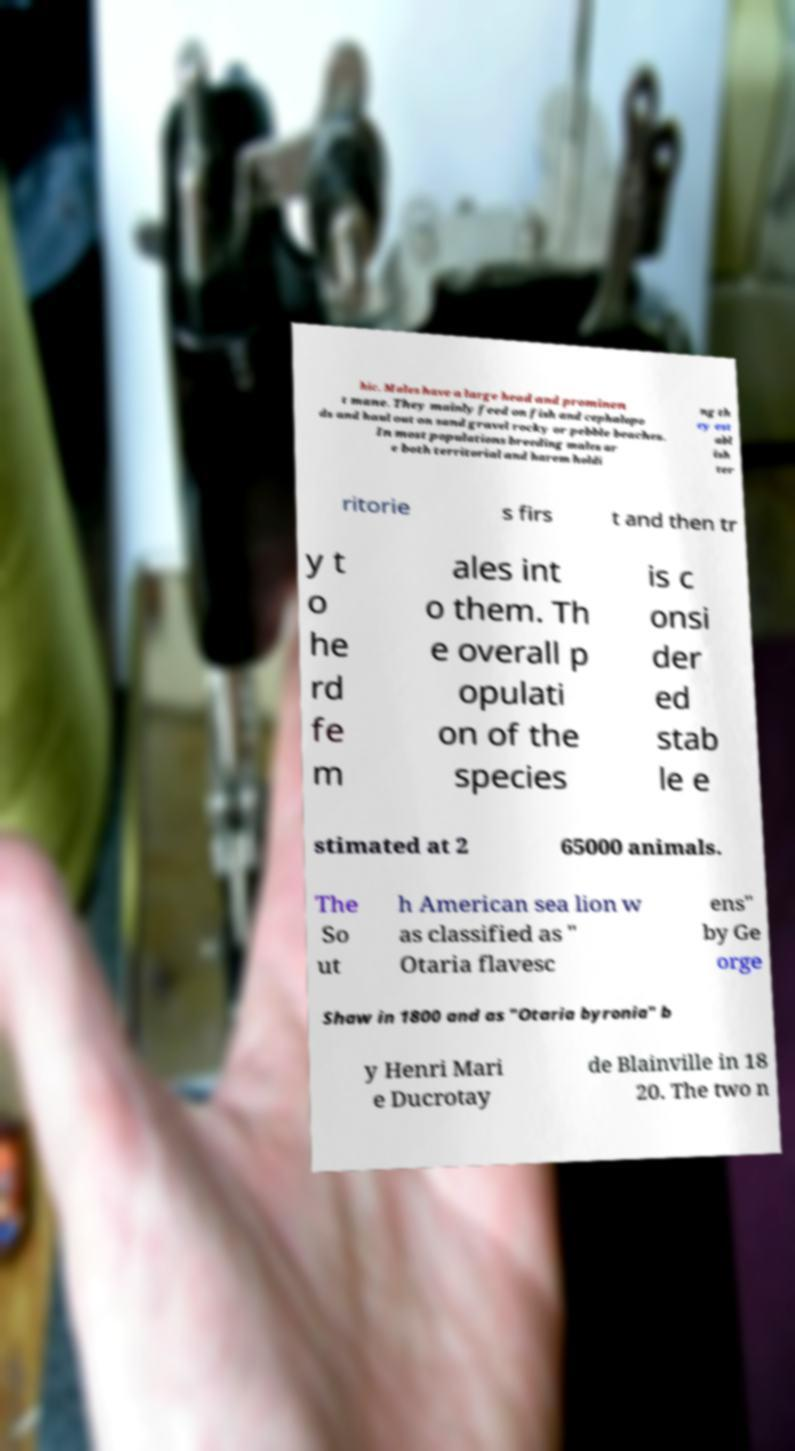Could you extract and type out the text from this image? hic. Males have a large head and prominen t mane. They mainly feed on fish and cephalopo ds and haul out on sand gravel rocky or pebble beaches. In most populations breeding males ar e both territorial and harem holdi ng th ey est abl ish ter ritorie s firs t and then tr y t o he rd fe m ales int o them. Th e overall p opulati on of the species is c onsi der ed stab le e stimated at 2 65000 animals. The So ut h American sea lion w as classified as " Otaria flavesc ens" by Ge orge Shaw in 1800 and as "Otaria byronia" b y Henri Mari e Ducrotay de Blainville in 18 20. The two n 